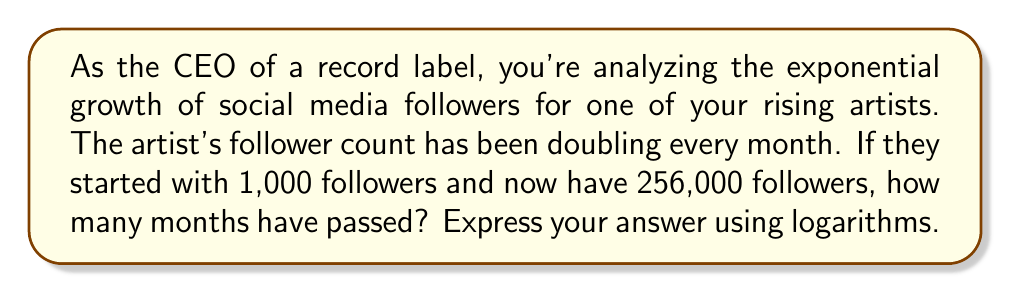Show me your answer to this math problem. Let's approach this step-by-step:

1) Let $x$ be the number of months that have passed.

2) We can express the growth as an exponential function:
   $1000 \cdot 2^x = 256000$

3) To solve for $x$, we can use logarithms. Let's divide both sides by 1000:
   $2^x = 256$

4) Now, we can take the logarithm (base 2) of both sides:
   $\log_2(2^x) = \log_2(256)$

5) Using the logarithm property $\log_a(a^x) = x$, we get:
   $x = \log_2(256)$

6) To evaluate $\log_2(256)$, we can use the change of base formula:
   $\log_2(256) = \frac{\log(256)}{\log(2)}$

7) $256 = 2^8$, so $\log_2(256) = 8$

Therefore, 8 months have passed.

This demonstrates how logarithms can be used to analyze exponential growth, which is common in social media follower counts. As a CEO, understanding this can help in making data-driven decisions about artist promotion and marketing strategies.
Answer: $x = \log_2(256) = 8$ months 